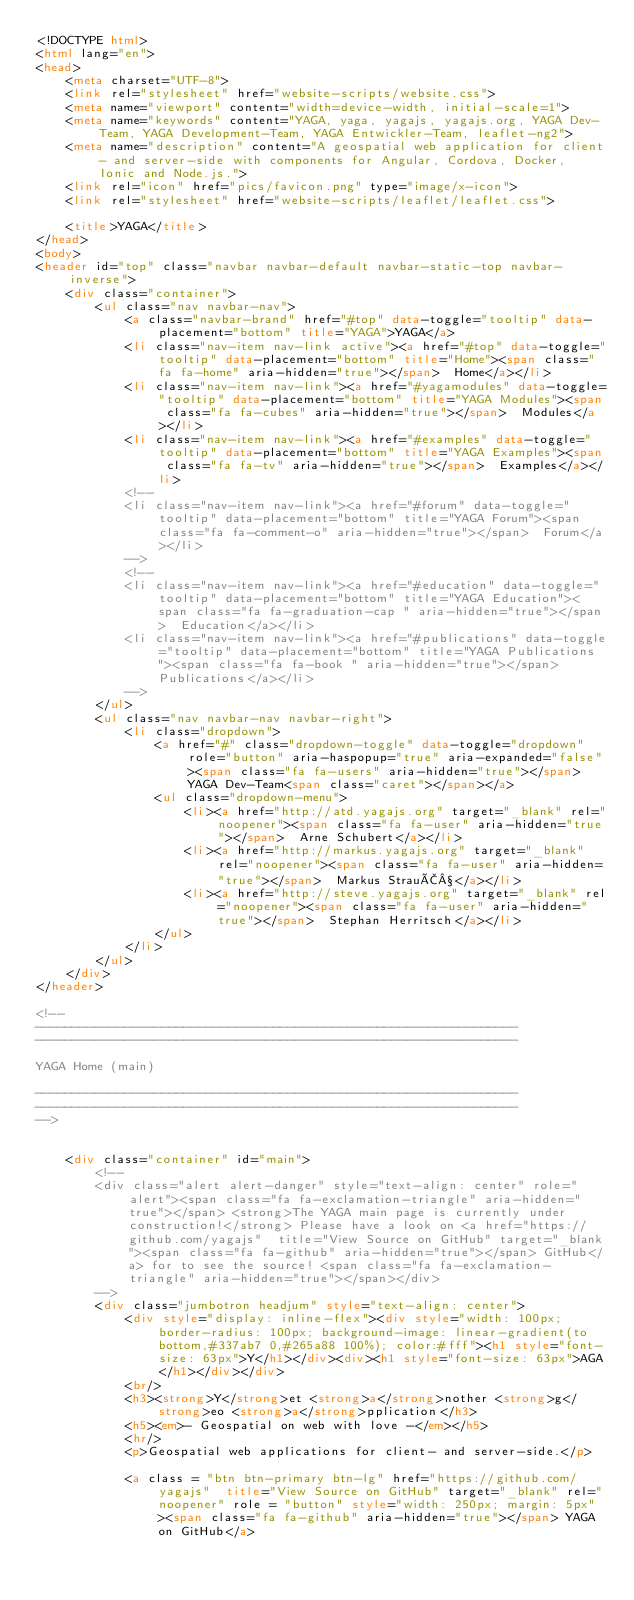<code> <loc_0><loc_0><loc_500><loc_500><_HTML_><!DOCTYPE html>
<html lang="en">
<head>
    <meta charset="UTF-8">
    <link rel="stylesheet" href="website-scripts/website.css">
    <meta name="viewport" content="width=device-width, initial-scale=1">
	<meta name="keywords" content="YAGA, yaga, yagajs, yagajs.org, YAGA Dev-Team, YAGA Development-Team, YAGA Entwickler-Team, leaflet-ng2">
	<meta name="description" content="A geospatial web application for client- and server-side with components for Angular, Cordova, Docker, Ionic and Node.js.">
	<link rel="icon" href="pics/favicon.png" type="image/x-icon">
    <link rel="stylesheet" href="website-scripts/leaflet/leaflet.css">
	
    <title>YAGA</title>
</head>
<body>
<header id="top" class="navbar navbar-default navbar-static-top navbar-inverse">
    <div class="container">
        <ul class="nav navbar-nav">
            <a class="navbar-brand" href="#top" data-toggle="tooltip" data-placement="bottom" title="YAGA">YAGA</a>
			<li class="nav-item nav-link active"><a href="#top" data-toggle="tooltip" data-placement="bottom" title="Home"><span class="fa fa-home" aria-hidden="true"></span>  Home</a></li>
			<li class="nav-item nav-link"><a href="#yagamodules" data-toggle="tooltip" data-placement="bottom" title="YAGA Modules"><span class="fa fa-cubes" aria-hidden="true"></span>  Modules</a></li>
            <li class="nav-item nav-link"><a href="#examples" data-toggle="tooltip" data-placement="bottom" title="YAGA Examples"><span class="fa fa-tv" aria-hidden="true"></span>  Examples</a></li>
            <!--
			<li class="nav-item nav-link"><a href="#forum" data-toggle="tooltip" data-placement="bottom" title="YAGA Forum"><span class="fa fa-comment-o" aria-hidden="true"></span>  Forum</a></li>
			-->
			<!--
			<li class="nav-item nav-link"><a href="#education" data-toggle="tooltip" data-placement="bottom" title="YAGA Education"><span class="fa fa-graduation-cap " aria-hidden="true"></span>  Education</a></li>
			<li class="nav-item nav-link"><a href="#publications" data-toggle="tooltip" data-placement="bottom" title="YAGA Publications"><span class="fa fa-book " aria-hidden="true"></span>  Publications</a></li>
			-->
        </ul>
		<ul class="nav navbar-nav navbar-right">
			<li class="dropdown">
                <a href="#" class="dropdown-toggle" data-toggle="dropdown" role="button" aria-haspopup="true" aria-expanded="false"><span class="fa fa-users" aria-hidden="true"></span>  YAGA Dev-Team<span class="caret"></span></a>
                <ul class="dropdown-menu">
                    <li><a href="http://atd.yagajs.org" target="_blank" rel="noopener"><span class="fa fa-user" aria-hidden="true"></span>  Arne Schubert</a></li>
                    <li><a href="http://markus.yagajs.org" target="_blank" rel="noopener"><span class="fa fa-user" aria-hidden="true"></span>  Markus StrauÃ</a></li>
                    <li><a href="http://steve.yagajs.org" target="_blank" rel="noopener"><span class="fa fa-user" aria-hidden="true"></span>  Stephan Herritsch</a></li>
                </ul>
            </li>
        </ul>
    </div>
</header>

<!--
-----------------------------------------------------------------
-----------------------------------------------------------------

YAGA Home (main)

-----------------------------------------------------------------
-----------------------------------------------------------------
-->


    <div class="container" id="main">
		<!--
		<div class="alert alert-danger" style="text-align: center" role="alert"><span class="fa fa-exclamation-triangle" aria-hidden="true"></span> <strong>The YAGA main page is currently under construction!</strong> Please have a look on <a href="https://github.com/yagajs"  title="View Source on GitHub" target="_blank"><span class="fa fa-github" aria-hidden="true"></span> GitHub</a> for to see the source! <span class="fa fa-exclamation-triangle" aria-hidden="true"></span></div>
		-->
		<div class="jumbotron headjum" style="text-align: center">
			<div style="display: inline-flex"><div style="width: 100px; border-radius: 100px; background-image: linear-gradient(to bottom,#337ab7 0,#265a88 100%); color:#fff"><h1 style="font-size: 63px">Y</h1></div><div><h1 style="font-size: 63px">AGA</h1></div></div>
			<br/>
			<h3><strong>Y</strong>et <strong>a</strong>nother <strong>g</strong>eo <strong>a</strong>pplication</h3>
			<h5><em>- Geospatial on web with love -</em></h5>
			<hr/>
			<p>Geospatial web applications for client- and server-side.</p>
			
			<a class = "btn btn-primary btn-lg" href="https://github.com/yagajs"  title="View Source on GitHub" target="_blank" rel="noopener" role = "button" style="width: 250px; margin: 5px"><span class="fa fa-github" aria-hidden="true"></span> YAGA on GitHub</a></code> 